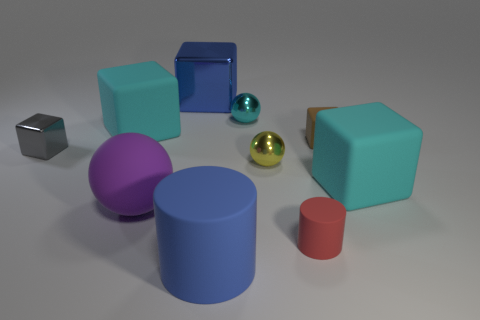Subtract all brown blocks. How many blocks are left? 4 Subtract all gray shiny blocks. How many blocks are left? 4 Subtract 1 blocks. How many blocks are left? 4 Subtract all purple cubes. Subtract all gray balls. How many cubes are left? 5 Subtract all cylinders. How many objects are left? 8 Subtract all rubber cylinders. Subtract all tiny red rubber objects. How many objects are left? 7 Add 1 blue metallic things. How many blue metallic things are left? 2 Add 8 tiny brown cubes. How many tiny brown cubes exist? 9 Subtract 0 red balls. How many objects are left? 10 